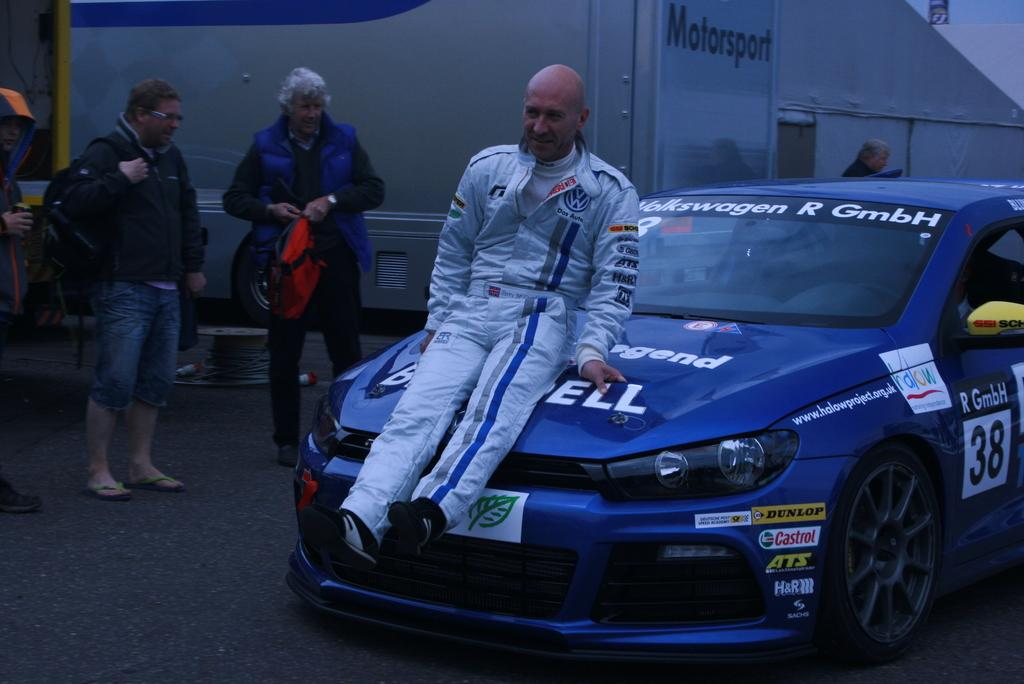Who is the main subject in the image? There is a man in the image. What is the man wearing? The man is wearing a white dress. What is the man doing in the image? The man is sitting on a car. How many people are on the left side of the image? There are three people on the left side of the image. What can be seen in the background of the image? There is a building in the background of the image. How many animals can be seen at the zoo in the image? There is no zoo present in the image, so it is not possible to determine the number of animals. What type of nerve is being stimulated by the man in the image? There is no indication in the image that the man is stimulating any nerves, so it cannot be determined from the picture. 